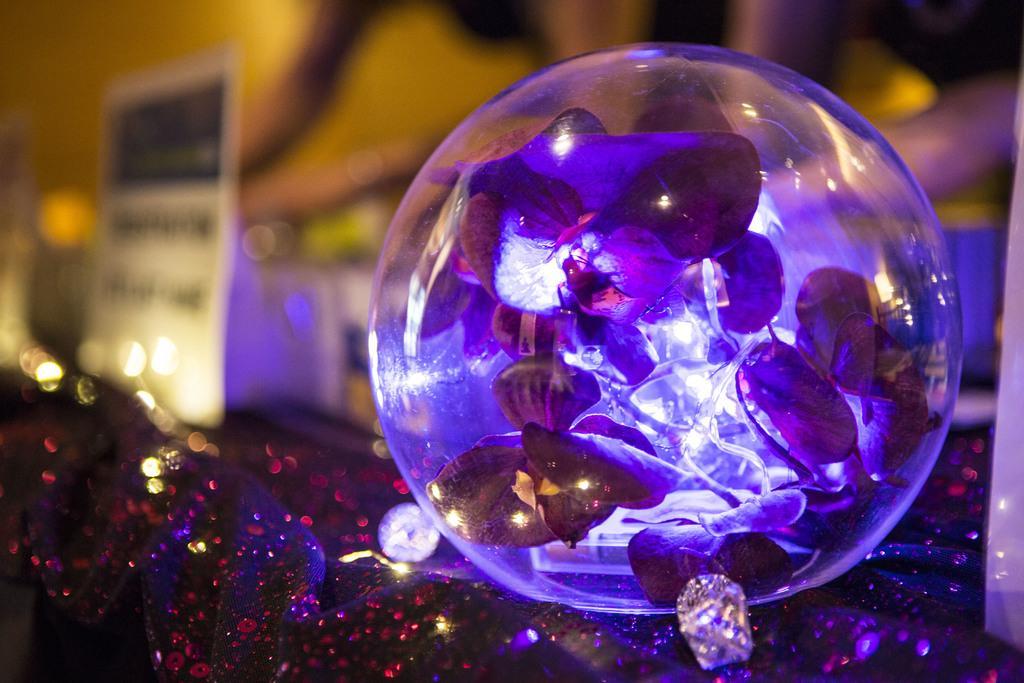Please provide a concise description of this image. In foreground we have shiny cloth which is shining in red color. In middle of the image we have crystal inside it plates are present which are shining in white and pink shade. On the top image is blur but it is in yellow color. 